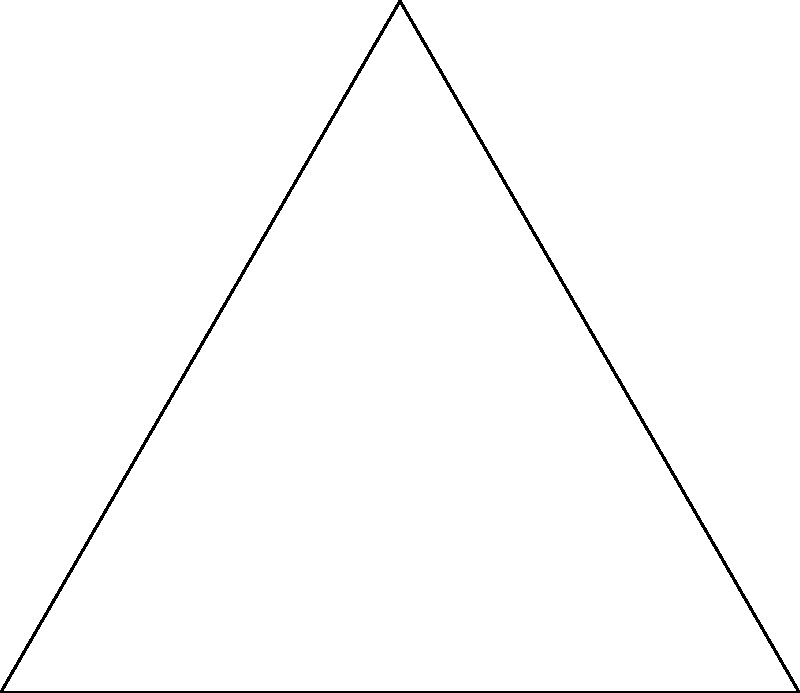As a boat captain using a sextant to determine your position, you measure the angle between the horizon and the sun to be 60°. What is the sun's altitude (h) above the horizon? To find the sun's altitude (h) using a sextant measurement, we need to understand the relationship between the measured angle and the altitude:

1. The sextant measures the angle between the horizon and the celestial object (in this case, the sun).
2. This measured angle is complementary to the altitude (h) we want to calculate.
3. In a right triangle, complementary angles add up to 90°.

Therefore, we can calculate the altitude (h) as follows:

1. Let x be the measured angle: $x = 60°$
2. The relationship between x and h: $x + h = 90°$
3. Solving for h: $h = 90° - x$
4. Substituting the given value: $h = 90° - 60°$
5. Calculating the result: $h = 30°$

Thus, the sun's altitude above the horizon is 30°.
Answer: 30° 